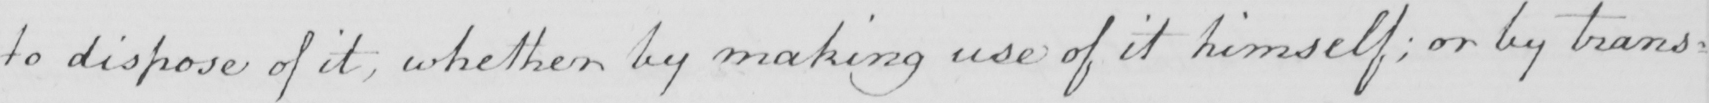Transcribe the text shown in this historical manuscript line. to dispose of it ; whether by making use of it himself ; or by trans- 